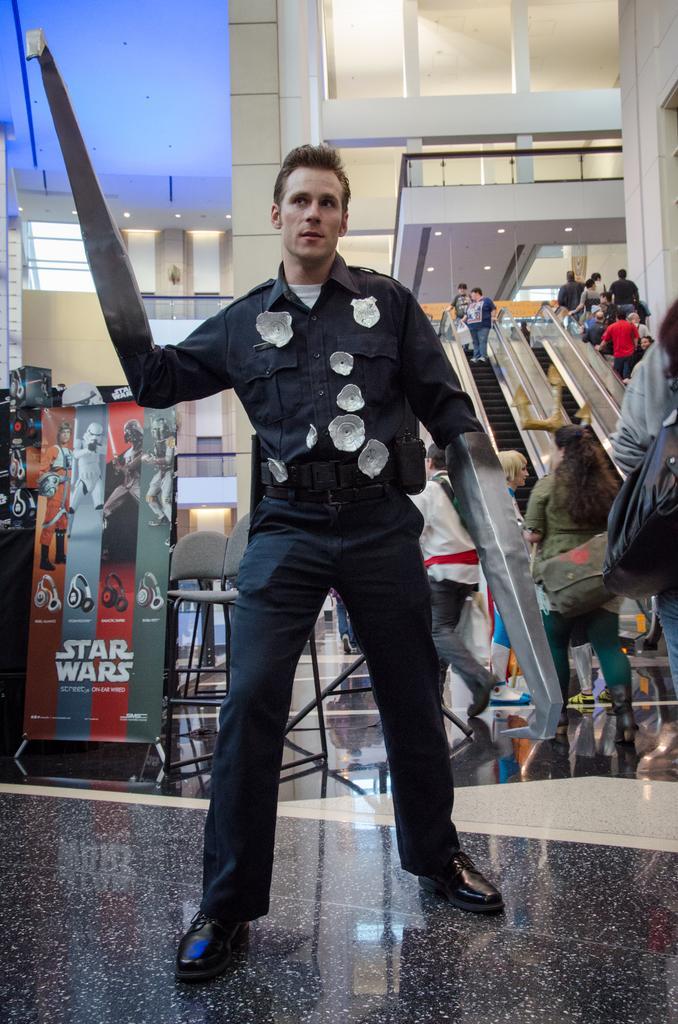How would you summarize this image in a sentence or two? In this image I can see the person with the dress. In the background I can see the group of people, escalators, chairs and the boards. I can see few people are with bags. I can see the lights at the top. I can see these people are inside the building. 